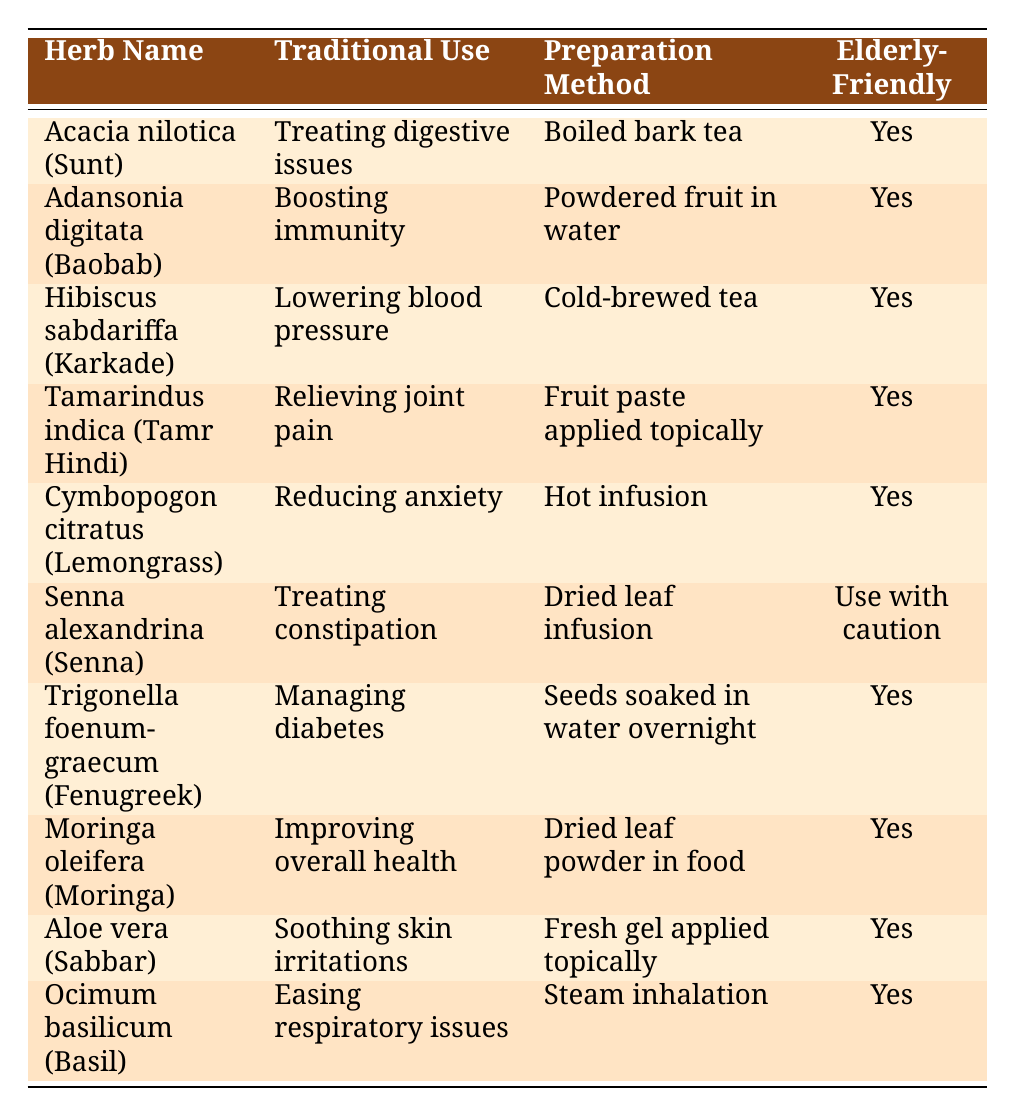What is the traditional use of Acacia nilotica? According to the table, Acacia nilotica is traditionally used for treating digestive issues.
Answer: Treating digestive issues Which herb is used for lowering blood pressure? The table indicates that Hibiscus sabdariffa, also known as Karkade, is used for lowering blood pressure.
Answer: Hibiscus sabdariffa (Karkade) How many herbs are considered elderly-friendly? By examining the table, we see that all herbs except for Senna alexandrina are marked as elderly-friendly. This results in 9 herbs being elderly-friendly.
Answer: 9 Is Senna alexandrina elderly-friendly? The table explicitly states that Senna alexandrina requires caution for the elderly, hence it is not considered elderly-friendly.
Answer: No Which herb requires a hot infusion for its preparation method? The preparation for Cymbopogon citratus, or Lemongrass, involves a hot infusion as listed in the table.
Answer: Cymbopogon citratus (Lemongrass) What are the uses for herbs that are elderly-friendly? By analyzing the table, we can compile the following uses for elderly-friendly herbs: treating digestive issues, boosting immunity, lowering blood pressure, relieving joint pain, reducing anxiety, managing diabetes, improving overall health, soothing skin irritations, and easing respiratory issues. This totals to 9 distinct uses.
Answer: 9 distinct uses What is the preparation method for Moringa oleifera? The table specifies that Moringa oleifera is prepared using dried leaf powder in food.
Answer: Dried leaf powder in food Which herb has the traditional use of managing diabetes, and is it elderly-friendly? The herb Trigonella foenum-graecum, or Fenugreek, is used for managing diabetes, and according to the table, it is marked as elderly-friendly.
Answer: Trigonella foenum-graecum (Fenugreek), Yes 